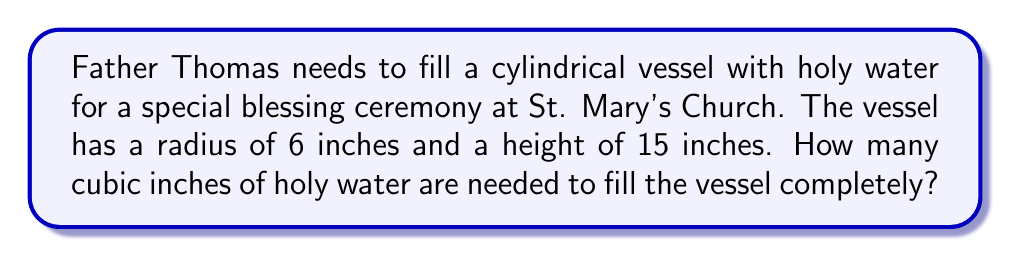Teach me how to tackle this problem. To solve this problem, we need to calculate the volume of a cylinder. The formula for the volume of a cylinder is:

$$V = \pi r^2 h$$

Where:
$V$ = volume
$r$ = radius of the base
$h$ = height of the cylinder

Given:
$r = 6$ inches
$h = 15$ inches

Let's substitute these values into the formula:

$$V = \pi (6 \text{ in})^2 (15 \text{ in})$$

Simplify:
$$V = \pi (36 \text{ in}^2) (15 \text{ in})$$
$$V = 540\pi \text{ in}^3$$

Using $\pi \approx 3.14159$, we can calculate the approximate volume:

$$V \approx 540 \times 3.14159 \text{ in}^3$$
$$V \approx 1696.46 \text{ in}^3$$

Rounding to the nearest cubic inch:

$$V \approx 1696 \text{ in}^3$$

Therefore, Father Thomas needs approximately 1696 cubic inches of holy water to fill the cylindrical vessel completely.
Answer: $1696 \text{ in}^3$ 